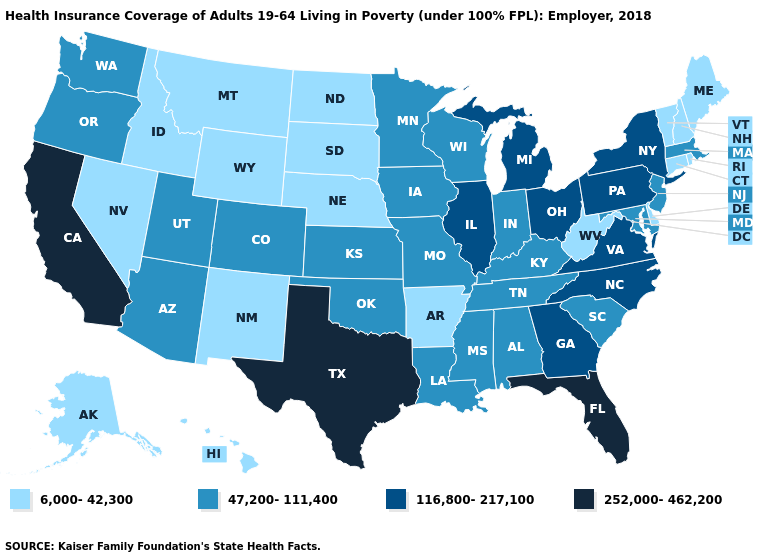What is the value of Alaska?
Give a very brief answer. 6,000-42,300. Name the states that have a value in the range 47,200-111,400?
Answer briefly. Alabama, Arizona, Colorado, Indiana, Iowa, Kansas, Kentucky, Louisiana, Maryland, Massachusetts, Minnesota, Mississippi, Missouri, New Jersey, Oklahoma, Oregon, South Carolina, Tennessee, Utah, Washington, Wisconsin. Name the states that have a value in the range 47,200-111,400?
Write a very short answer. Alabama, Arizona, Colorado, Indiana, Iowa, Kansas, Kentucky, Louisiana, Maryland, Massachusetts, Minnesota, Mississippi, Missouri, New Jersey, Oklahoma, Oregon, South Carolina, Tennessee, Utah, Washington, Wisconsin. What is the highest value in the USA?
Keep it brief. 252,000-462,200. Among the states that border West Virginia , does Kentucky have the lowest value?
Concise answer only. Yes. Which states have the lowest value in the USA?
Be succinct. Alaska, Arkansas, Connecticut, Delaware, Hawaii, Idaho, Maine, Montana, Nebraska, Nevada, New Hampshire, New Mexico, North Dakota, Rhode Island, South Dakota, Vermont, West Virginia, Wyoming. Name the states that have a value in the range 116,800-217,100?
Be succinct. Georgia, Illinois, Michigan, New York, North Carolina, Ohio, Pennsylvania, Virginia. What is the value of Minnesota?
Short answer required. 47,200-111,400. Does Colorado have a higher value than Delaware?
Concise answer only. Yes. Which states have the lowest value in the USA?
Concise answer only. Alaska, Arkansas, Connecticut, Delaware, Hawaii, Idaho, Maine, Montana, Nebraska, Nevada, New Hampshire, New Mexico, North Dakota, Rhode Island, South Dakota, Vermont, West Virginia, Wyoming. What is the value of New Hampshire?
Keep it brief. 6,000-42,300. Does Florida have the highest value in the South?
Answer briefly. Yes. Name the states that have a value in the range 116,800-217,100?
Keep it brief. Georgia, Illinois, Michigan, New York, North Carolina, Ohio, Pennsylvania, Virginia. Which states have the highest value in the USA?
Write a very short answer. California, Florida, Texas. Does Virginia have the same value as Illinois?
Quick response, please. Yes. 